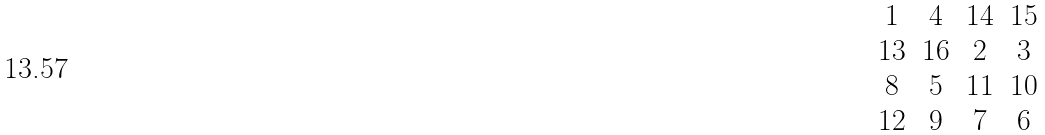Convert formula to latex. <formula><loc_0><loc_0><loc_500><loc_500>\begin{matrix} 1 & 4 & 1 4 & 1 5 \\ 1 3 & 1 6 & 2 & 3 \\ 8 & 5 & 1 1 & 1 0 \\ 1 2 & 9 & 7 & 6 \end{matrix}</formula> 